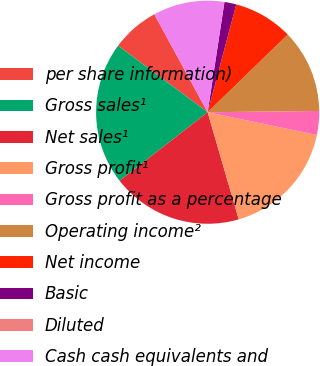Convert chart. <chart><loc_0><loc_0><loc_500><loc_500><pie_chart><fcel>per share information)<fcel>Gross sales¹<fcel>Net sales¹<fcel>Gross profit¹<fcel>Gross profit as a percentage<fcel>Operating income²<fcel>Net income<fcel>Basic<fcel>Diluted<fcel>Cash cash equivalents and<nl><fcel>6.9%<fcel>20.69%<fcel>18.97%<fcel>17.24%<fcel>3.45%<fcel>12.07%<fcel>8.62%<fcel>1.72%<fcel>0.0%<fcel>10.34%<nl></chart> 